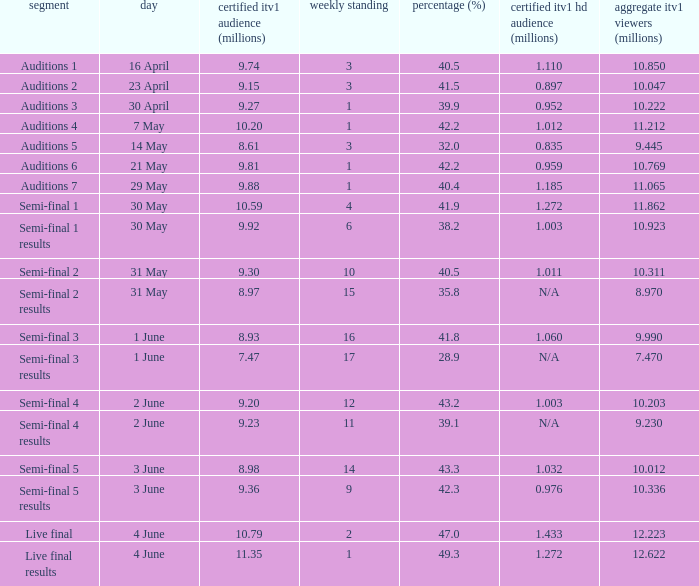What was the official ITV1 rating in millions of the Live Final Results episode? 11.35. 